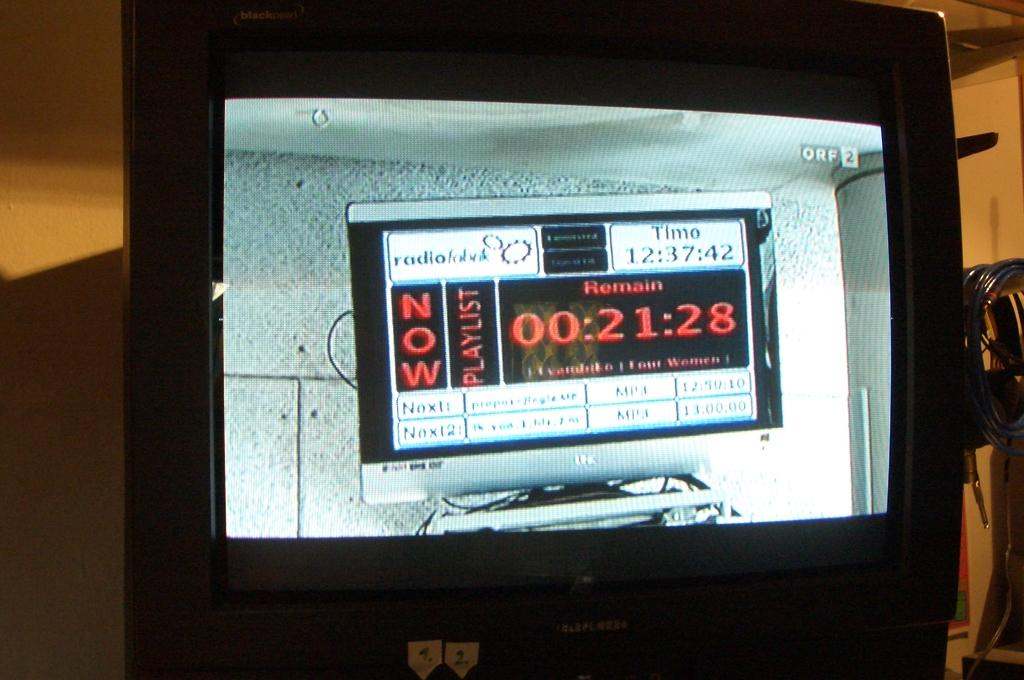Provide a one-sentence caption for the provided image. Television that shows a time for the now playlist radio. 